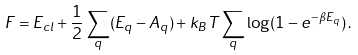Convert formula to latex. <formula><loc_0><loc_0><loc_500><loc_500>F = E _ { c l } + \frac { 1 } { 2 } \sum _ { q } ( E _ { q } - A _ { q } ) + k _ { B } T \sum _ { q } \log ( 1 - e ^ { - \beta E _ { q } } ) \, .</formula> 